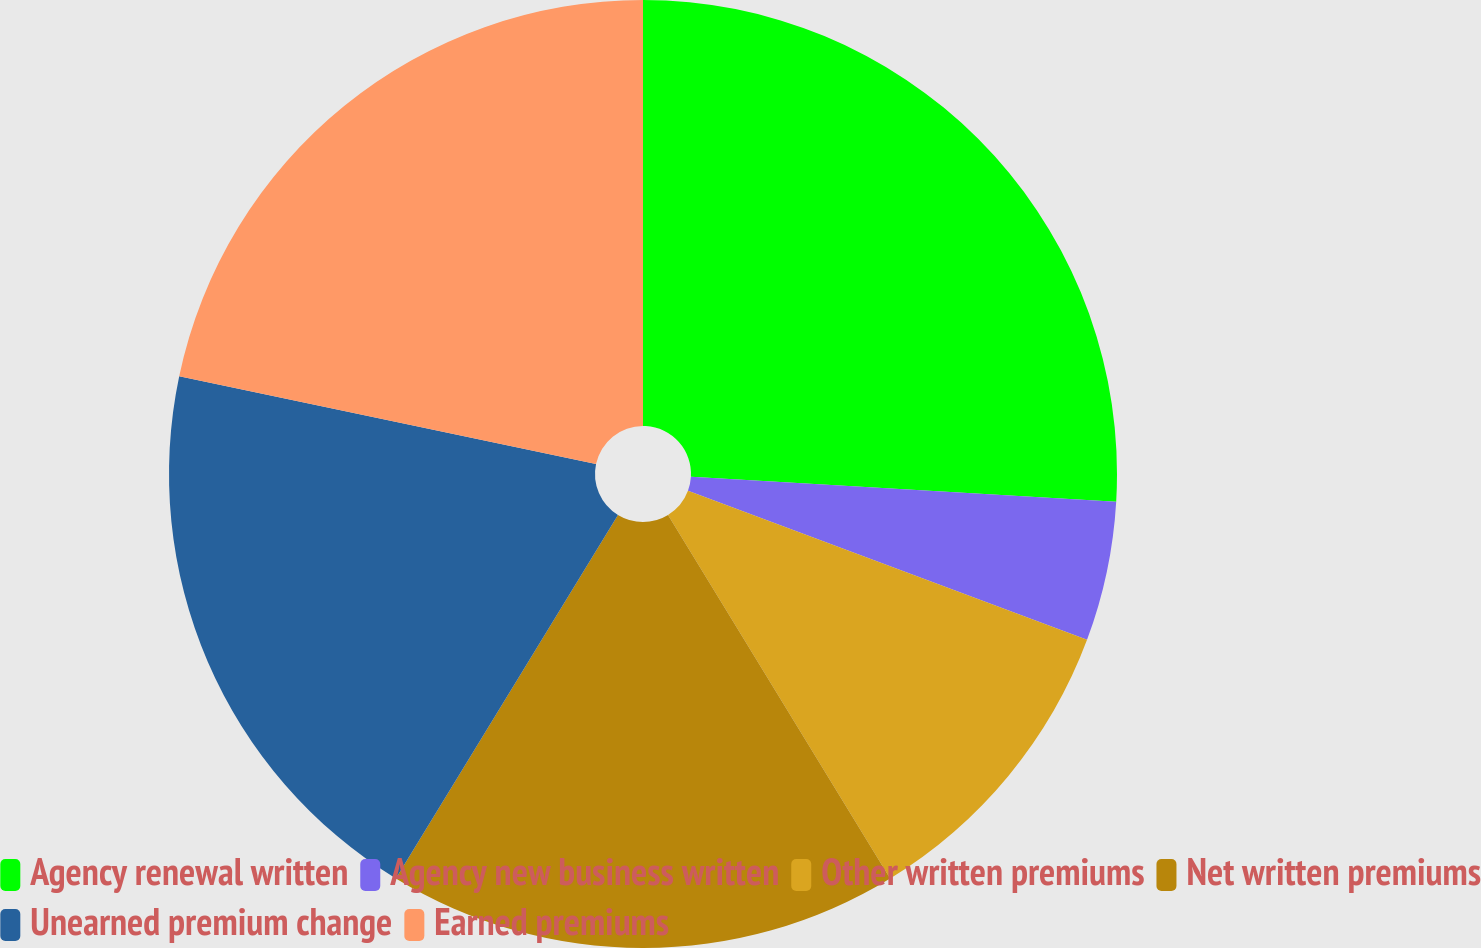Convert chart. <chart><loc_0><loc_0><loc_500><loc_500><pie_chart><fcel>Agency renewal written<fcel>Agency new business written<fcel>Other written premiums<fcel>Net written premiums<fcel>Unearned premium change<fcel>Earned premiums<nl><fcel>25.93%<fcel>4.76%<fcel>10.58%<fcel>17.46%<fcel>19.58%<fcel>21.69%<nl></chart> 